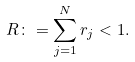Convert formula to latex. <formula><loc_0><loc_0><loc_500><loc_500>R \colon = \sum _ { j = 1 } ^ { N } r _ { j } < 1 .</formula> 